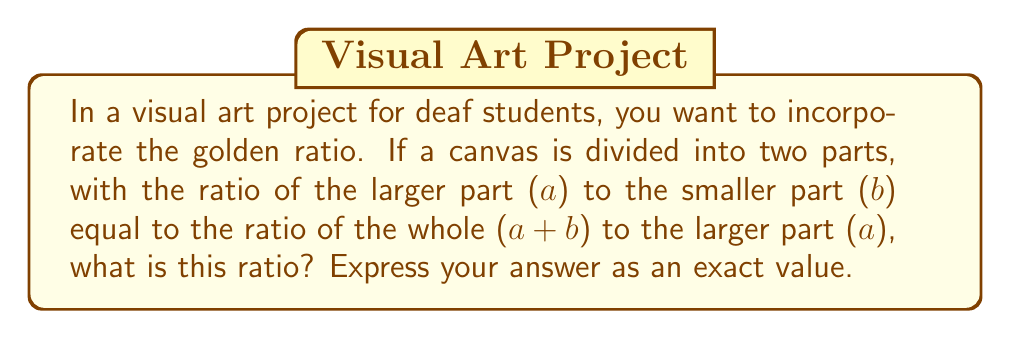Can you answer this question? Let's approach this step-by-step:

1) The golden ratio is defined by the equation:

   $$\frac{a}{b} = \frac{a+b}{a}$$

2) Let's call this ratio $\phi$. So we have:

   $$\phi = \frac{a}{b} = \frac{a+b}{a}$$

3) Cross multiply:

   $$a^2 = b(a+b)$$

4) Expand the right side:

   $$a^2 = ab + b^2$$

5) Subtract $ab$ from both sides:

   $$a^2 - ab = b^2$$

6) Factor out $a$ from the left side:

   $$a(a - b) = b^2$$

7) Divide both sides by $b^2$:

   $$\frac{a}{b}\left(\frac{a}{b} - 1\right) = 1$$

8) Substitute $\phi$ for $\frac{a}{b}$:

   $$\phi(\phi - 1) = 1$$

9) Expand:

   $$\phi^2 - \phi - 1 = 0$$

10) This is a quadratic equation. We can solve it using the quadratic formula:

    $$\phi = \frac{-b \pm \sqrt{b^2 - 4ac}}{2a}$$

    Where $a=1$, $b=-1$, and $c=-1$

11) Plugging in these values:

    $$\phi = \frac{1 \pm \sqrt{1 - 4(1)(-1)}}{2(1)} = \frac{1 \pm \sqrt{5}}{2}$$

12) Since we're looking for a positive ratio, we take the positive root:

    $$\phi = \frac{1 + \sqrt{5}}{2}$$

This is the exact value of the golden ratio.
Answer: $\frac{1 + \sqrt{5}}{2}$ 